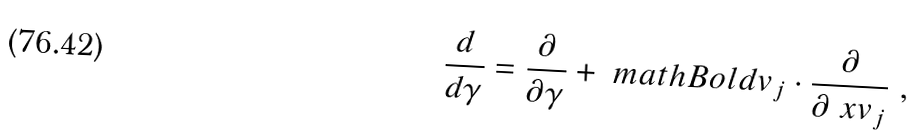<formula> <loc_0><loc_0><loc_500><loc_500>\frac { d } { d \gamma } = \frac { \partial } { \partial \gamma } + \ m a t h B o l d { v } _ { j } \cdot \frac { \partial } { \partial \ x v _ { j } } \ ,</formula> 